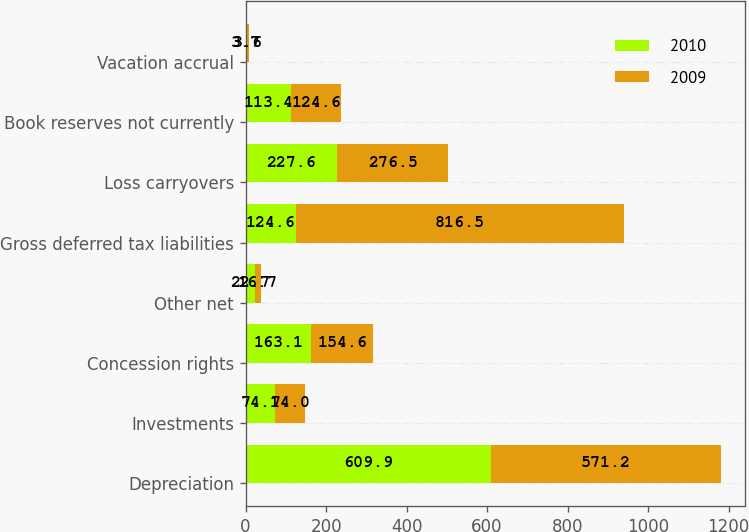Convert chart. <chart><loc_0><loc_0><loc_500><loc_500><stacked_bar_chart><ecel><fcel>Depreciation<fcel>Investments<fcel>Concession rights<fcel>Other net<fcel>Gross deferred tax liabilities<fcel>Loss carryovers<fcel>Book reserves not currently<fcel>Vacation accrual<nl><fcel>2010<fcel>609.9<fcel>74.1<fcel>163.1<fcel>22.7<fcel>124.6<fcel>227.6<fcel>113.4<fcel>3.7<nl><fcel>2009<fcel>571.2<fcel>74<fcel>154.6<fcel>16.7<fcel>816.5<fcel>276.5<fcel>124.6<fcel>3.6<nl></chart> 